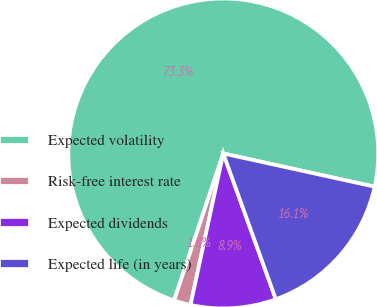Convert chart. <chart><loc_0><loc_0><loc_500><loc_500><pie_chart><fcel>Expected volatility<fcel>Risk-free interest rate<fcel>Expected dividends<fcel>Expected life (in years)<nl><fcel>73.29%<fcel>1.75%<fcel>8.9%<fcel>16.05%<nl></chart> 